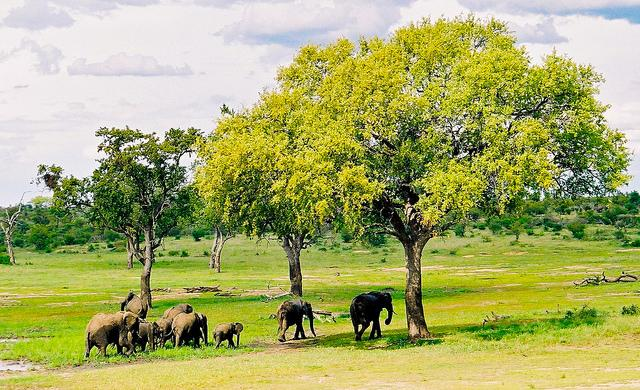How many elephants are there to lead this herd? two 